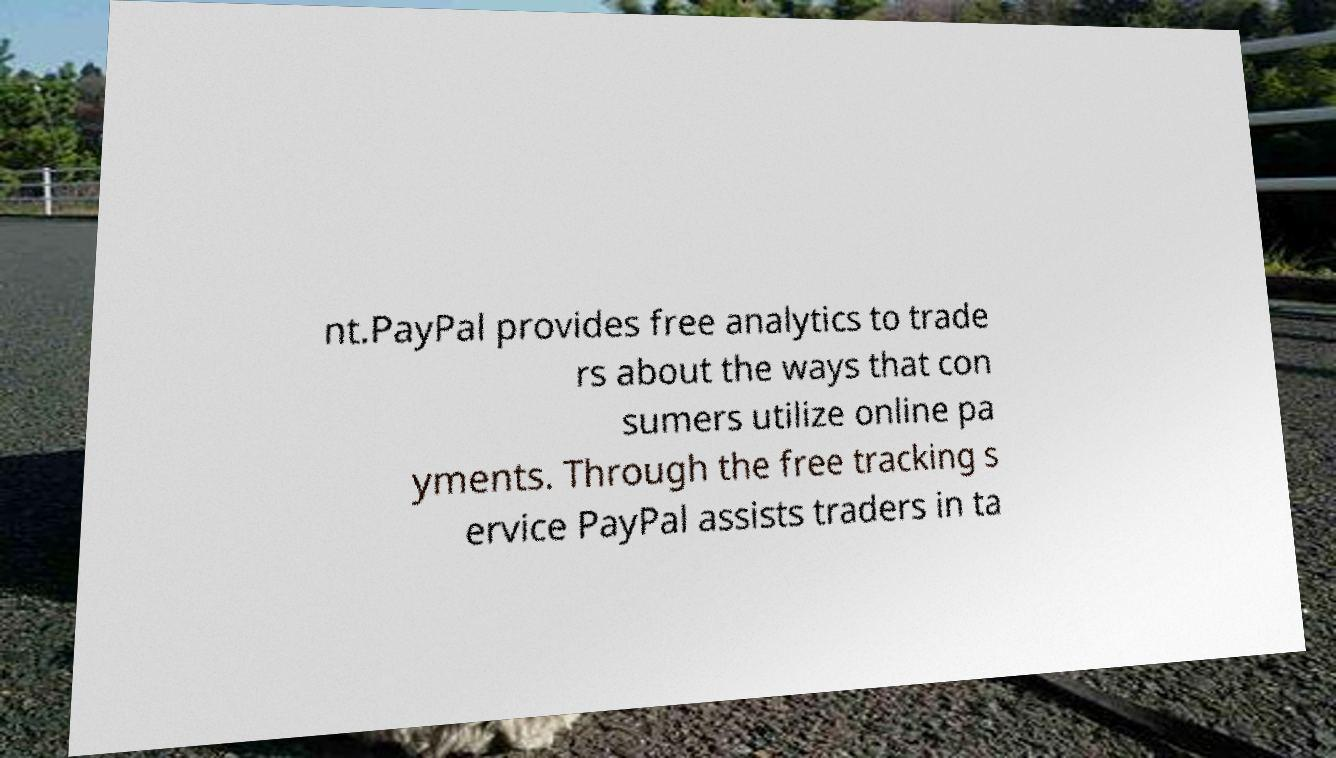There's text embedded in this image that I need extracted. Can you transcribe it verbatim? nt.PayPal provides free analytics to trade rs about the ways that con sumers utilize online pa yments. Through the free tracking s ervice PayPal assists traders in ta 